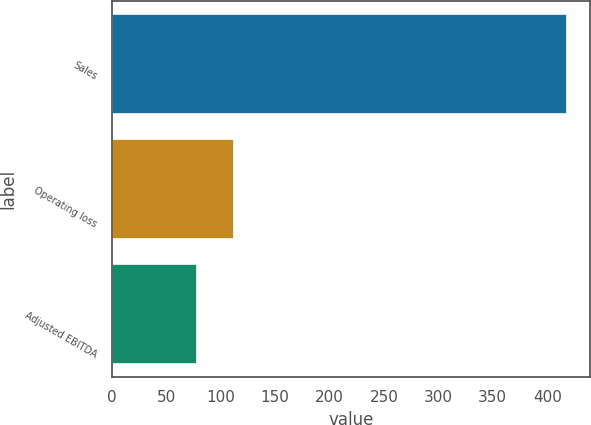Convert chart to OTSL. <chart><loc_0><loc_0><loc_500><loc_500><bar_chart><fcel>Sales<fcel>Operating loss<fcel>Adjusted EBITDA<nl><fcel>418.3<fcel>111.85<fcel>77.8<nl></chart> 